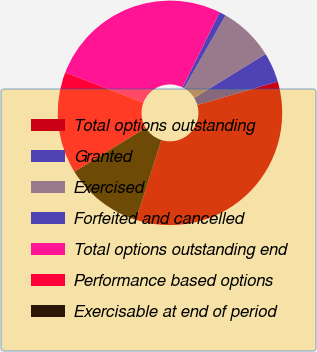Convert chart to OTSL. <chart><loc_0><loc_0><loc_500><loc_500><pie_chart><fcel>Total options outstanding<fcel>Granted<fcel>Exercised<fcel>Forfeited and cancelled<fcel>Total options outstanding end<fcel>Performance based options<fcel>Exercisable at end of period<nl><fcel>34.4%<fcel>4.29%<fcel>7.96%<fcel>0.95%<fcel>26.44%<fcel>14.65%<fcel>11.31%<nl></chart> 